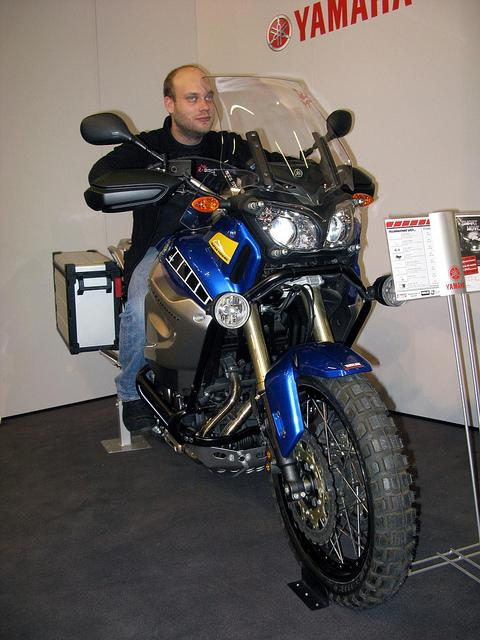What brand is the motorcycle? Please explain your reasoning. yamaha. A motorcycle has a brand logo on it. 